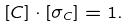<formula> <loc_0><loc_0><loc_500><loc_500>[ C ] \cdot [ \sigma _ { C } ] = 1 .</formula> 